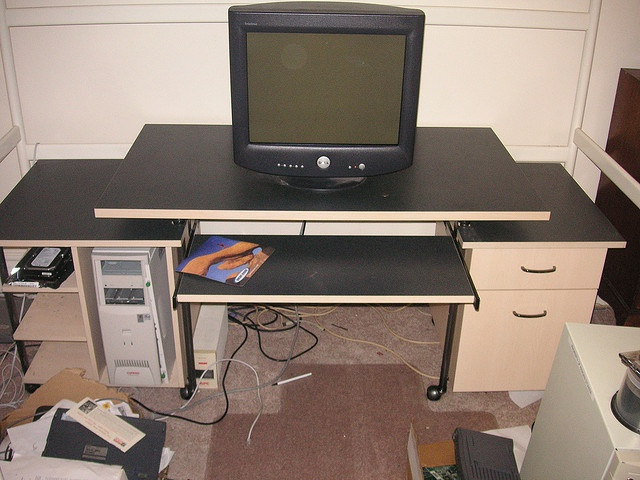Describe the objects in this image and their specific colors. I can see a tv in darkgray, gray, black, and lightgray tones in this image. 